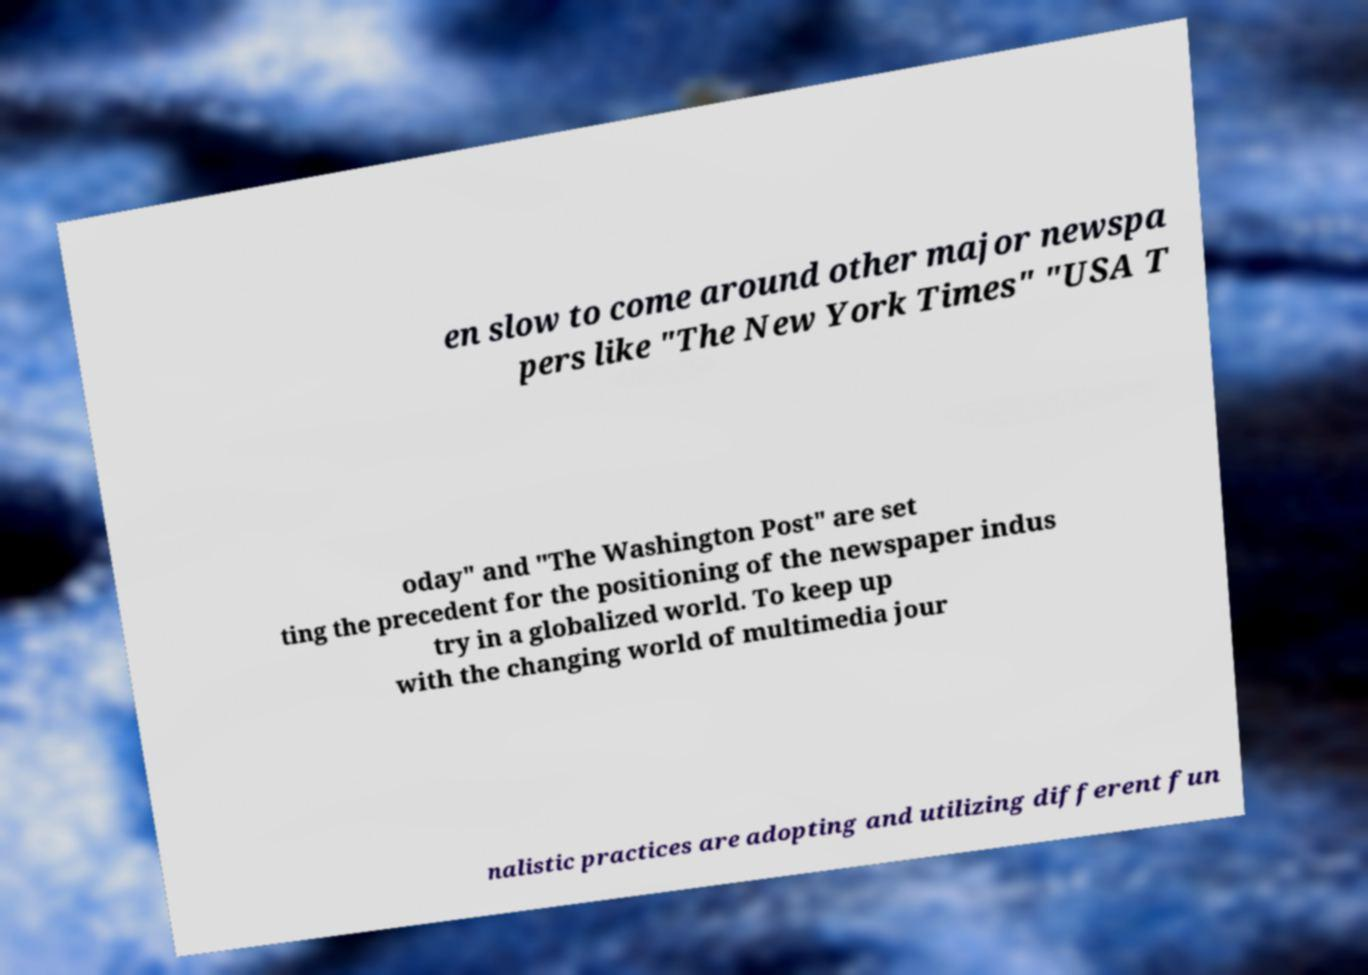There's text embedded in this image that I need extracted. Can you transcribe it verbatim? en slow to come around other major newspa pers like "The New York Times" "USA T oday" and "The Washington Post" are set ting the precedent for the positioning of the newspaper indus try in a globalized world. To keep up with the changing world of multimedia jour nalistic practices are adopting and utilizing different fun 